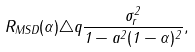Convert formula to latex. <formula><loc_0><loc_0><loc_500><loc_500>R _ { M S D } ( \alpha ) \triangle q \frac { \sigma ^ { 2 } _ { r } } { 1 - a ^ { 2 } ( 1 - \alpha ) ^ { 2 } } ,</formula> 